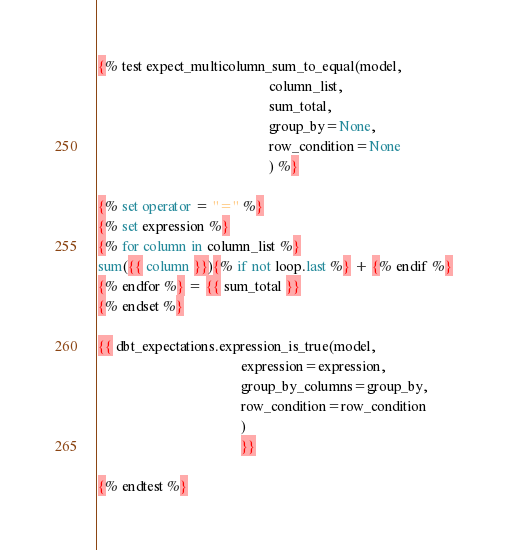Convert code to text. <code><loc_0><loc_0><loc_500><loc_500><_SQL_>
{% test expect_multicolumn_sum_to_equal(model,
                                                column_list,
                                                sum_total,
                                                group_by=None,
                                                row_condition=None
                                                ) %}

{% set operator = "=" %}
{% set expression %}
{% for column in column_list %}
sum({{ column }}){% if not loop.last %} + {% endif %}
{% endfor %} = {{ sum_total }}
{% endset %}

{{ dbt_expectations.expression_is_true(model,
                                        expression=expression,
                                        group_by_columns=group_by,
                                        row_condition=row_condition
                                        )
                                        }}

{% endtest %}
</code> 